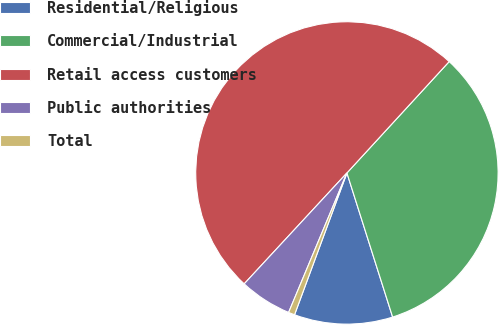Convert chart to OTSL. <chart><loc_0><loc_0><loc_500><loc_500><pie_chart><fcel>Residential/Religious<fcel>Commercial/Industrial<fcel>Retail access customers<fcel>Public authorities<fcel>Total<nl><fcel>10.52%<fcel>33.29%<fcel>49.93%<fcel>5.59%<fcel>0.67%<nl></chart> 